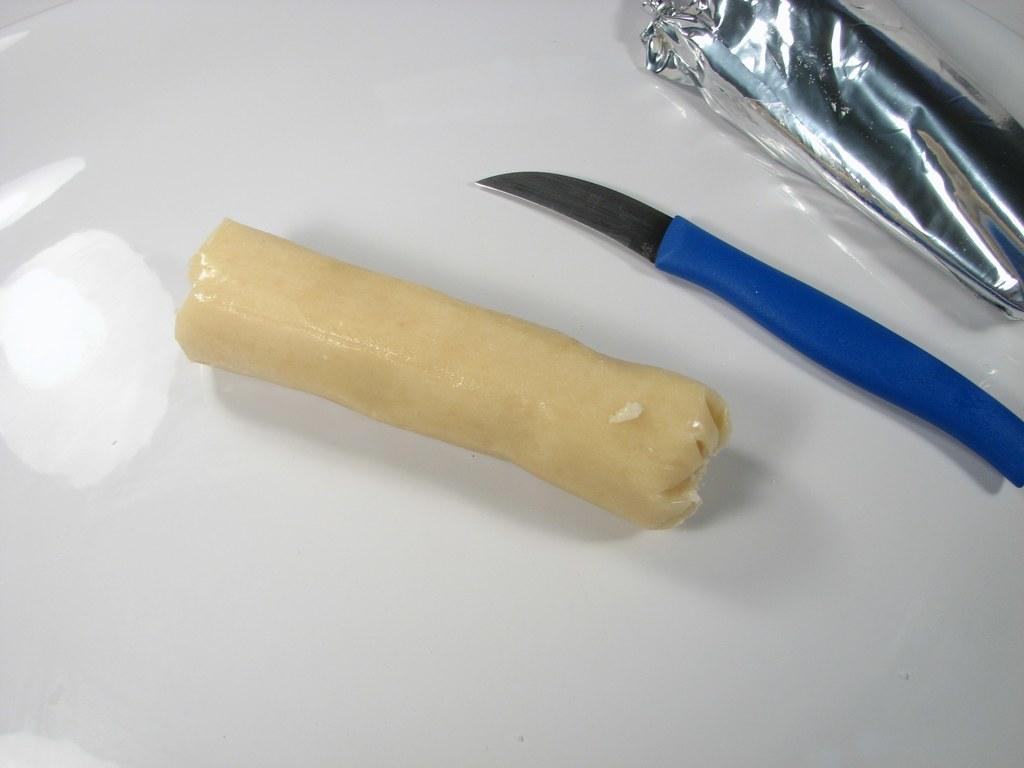Please provide a concise description of this image. In this image, we can see some object, knife and cover is placed on the white surface. 